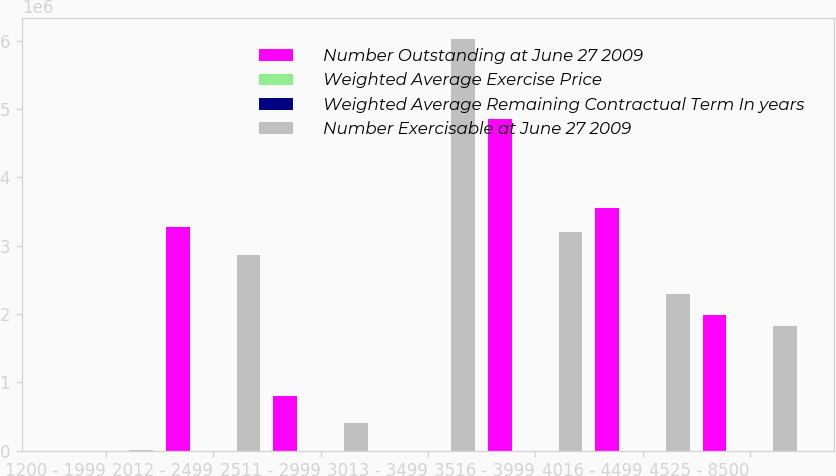Convert chart to OTSL. <chart><loc_0><loc_0><loc_500><loc_500><stacked_bar_chart><ecel><fcel>1200 - 1999<fcel>2012 - 2499<fcel>2511 - 2999<fcel>3013 - 3499<fcel>3516 - 3999<fcel>4016 - 4499<fcel>4525 - 8500<nl><fcel>Number Outstanding at June 27 2009<fcel>45.75<fcel>3.27408e+06<fcel>801744<fcel>45.75<fcel>4.84715e+06<fcel>3.54686e+06<fcel>1.98204e+06<nl><fcel>Weighted Average Exercise Price<fcel>6.46<fcel>3.59<fcel>6.03<fcel>3.3<fcel>4.49<fcel>4.25<fcel>2.72<nl><fcel>Weighted Average Remaining Contractual Term In years<fcel>12.98<fcel>21.34<fcel>27.32<fcel>32.77<fcel>37.14<fcel>41.93<fcel>49.57<nl><fcel>Number Exercisable at June 27 2009<fcel>5969<fcel>2.86206e+06<fcel>401745<fcel>6.02915e+06<fcel>3.2006e+06<fcel>2.28976e+06<fcel>1.82861e+06<nl></chart> 